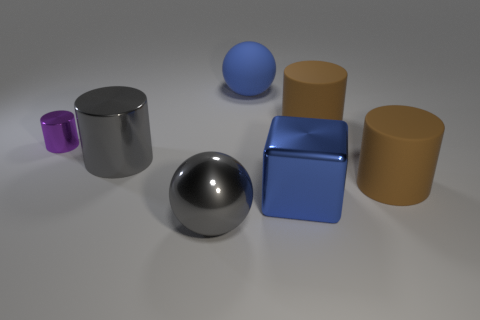Add 1 gray metallic cylinders. How many objects exist? 8 Subtract all small purple metal cylinders. How many cylinders are left? 3 Subtract all spheres. How many objects are left? 5 Subtract 1 cubes. How many cubes are left? 0 Add 2 metallic objects. How many metallic objects are left? 6 Add 3 small yellow objects. How many small yellow objects exist? 3 Subtract all brown cylinders. How many cylinders are left? 2 Subtract 0 red balls. How many objects are left? 7 Subtract all brown blocks. Subtract all red cylinders. How many blocks are left? 1 Subtract all cyan cylinders. How many purple balls are left? 0 